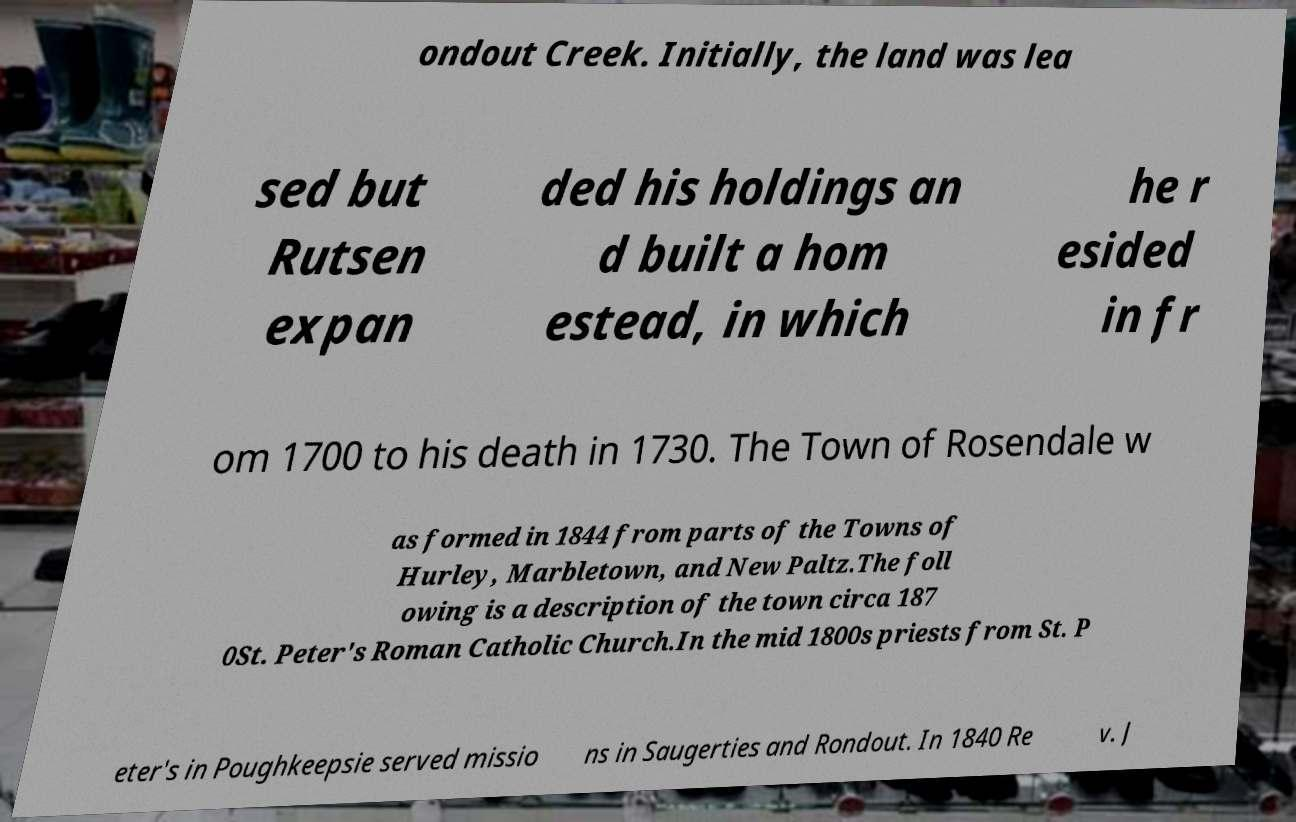Can you accurately transcribe the text from the provided image for me? ondout Creek. Initially, the land was lea sed but Rutsen expan ded his holdings an d built a hom estead, in which he r esided in fr om 1700 to his death in 1730. The Town of Rosendale w as formed in 1844 from parts of the Towns of Hurley, Marbletown, and New Paltz.The foll owing is a description of the town circa 187 0St. Peter's Roman Catholic Church.In the mid 1800s priests from St. P eter's in Poughkeepsie served missio ns in Saugerties and Rondout. In 1840 Re v. J 